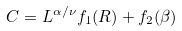<formula> <loc_0><loc_0><loc_500><loc_500>C = L ^ { \alpha / \nu } f _ { 1 } ( R ) + f _ { 2 } ( \beta )</formula> 